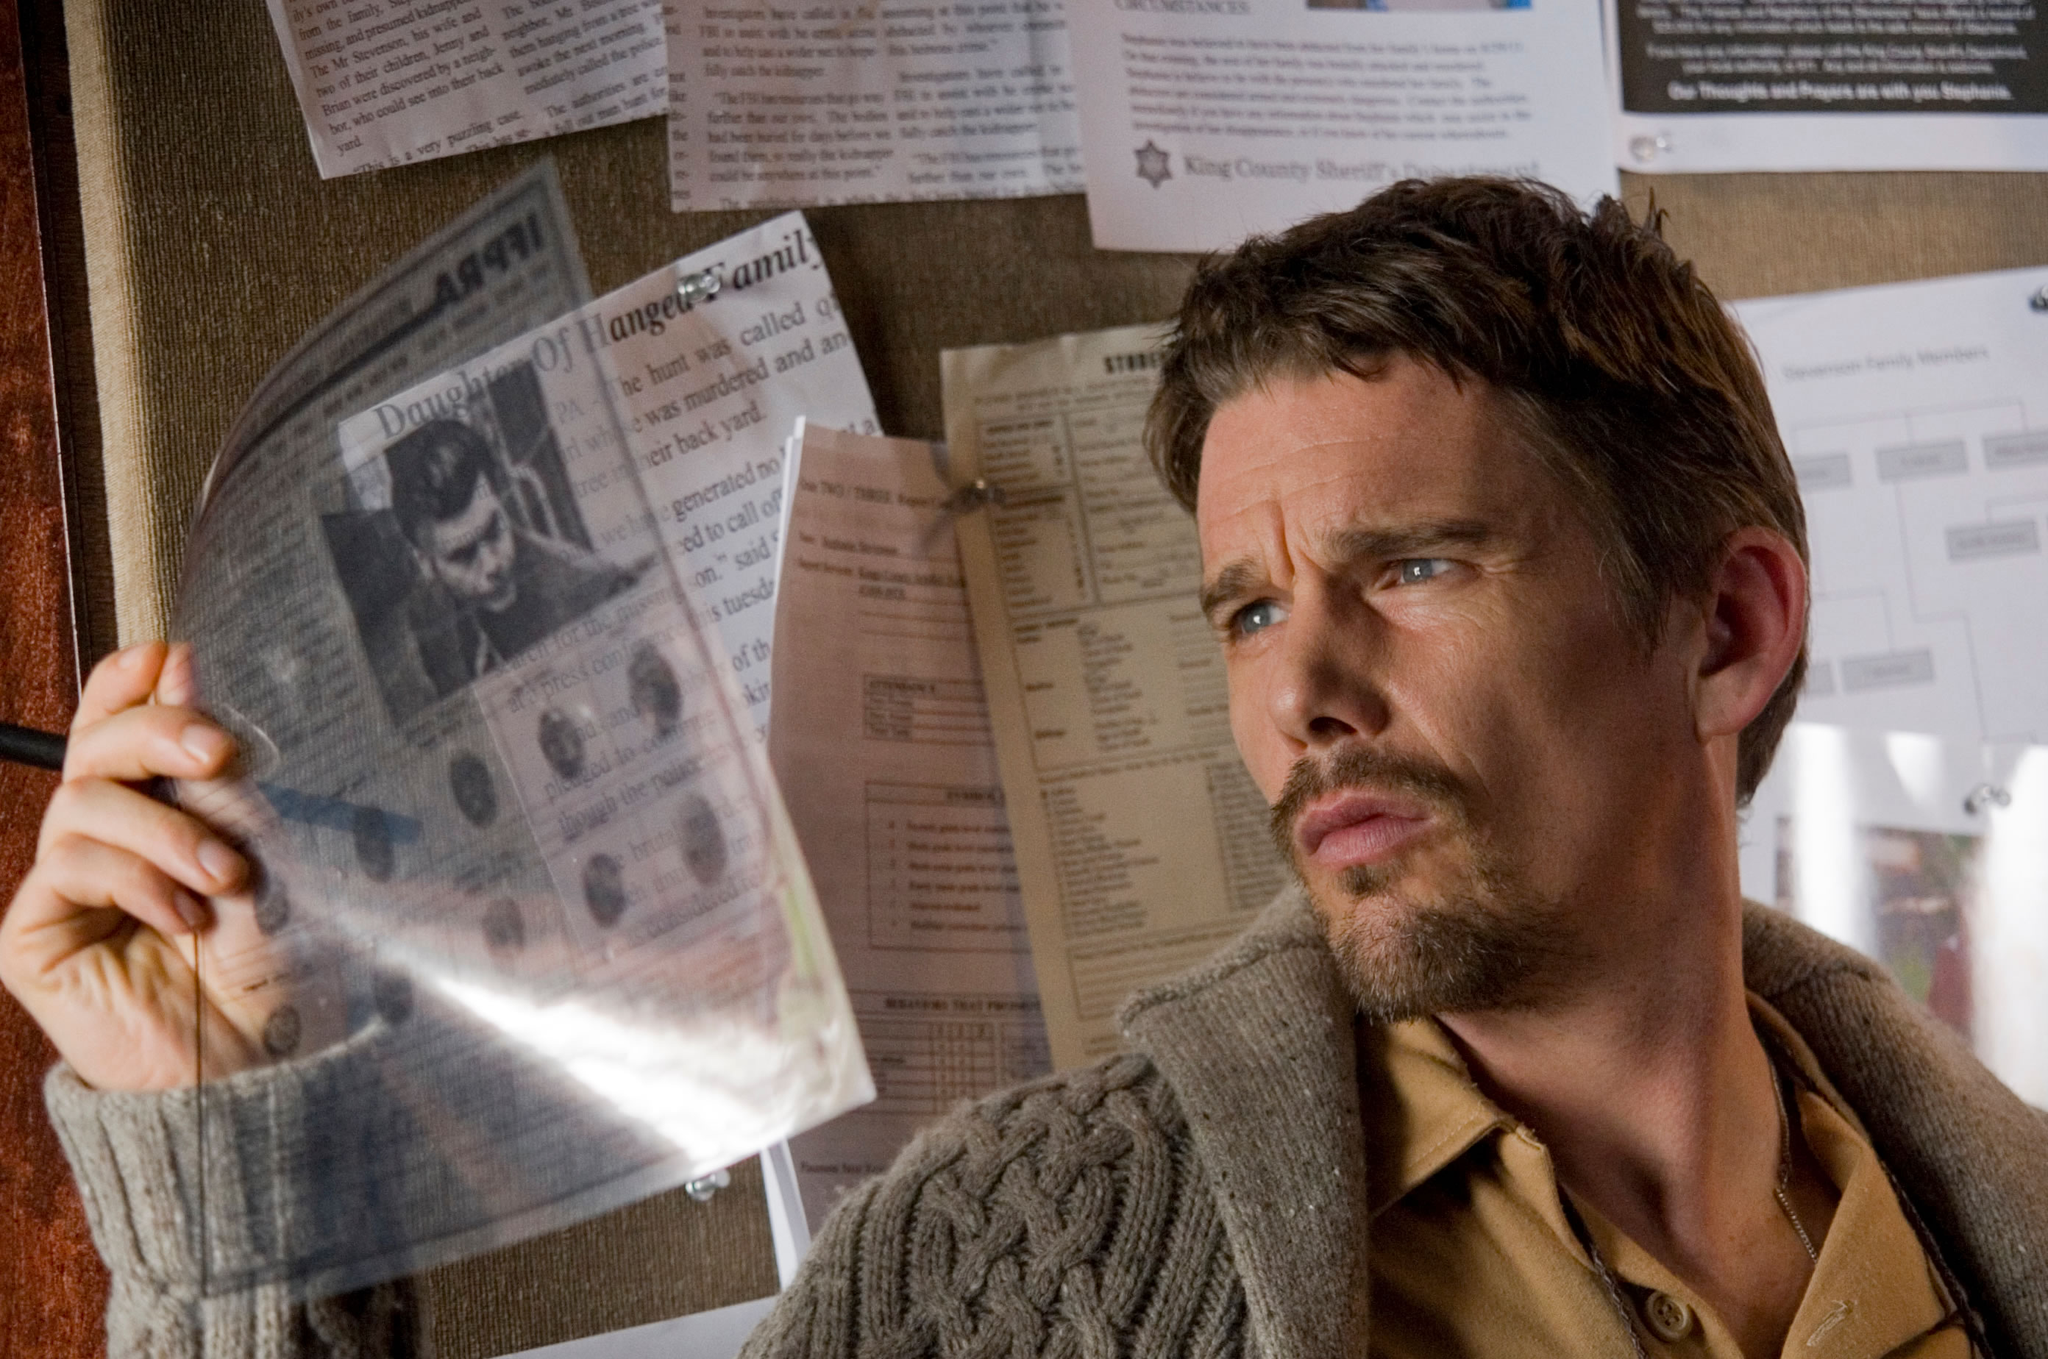What does his expression tell us about the situation? His expression is one of deep contemplation and slight concern, indicating the gravity of the situation or the complexity of the problem he is handling. The furrowed brows and focused gaze suggest he is in the middle of a critical decision-making moment or has just come across an important revelation in his research. How might his attire contribute to the scene's mood? His casual yet rugged attire, consisting of a knit sweater and jacket, gives him a practical and ready-for-action look, which aligns with the investigative or hard-working nature of his activities. This style adds a personal, everyday relatability to the character, enhancing the immersive quality of the scenario. 